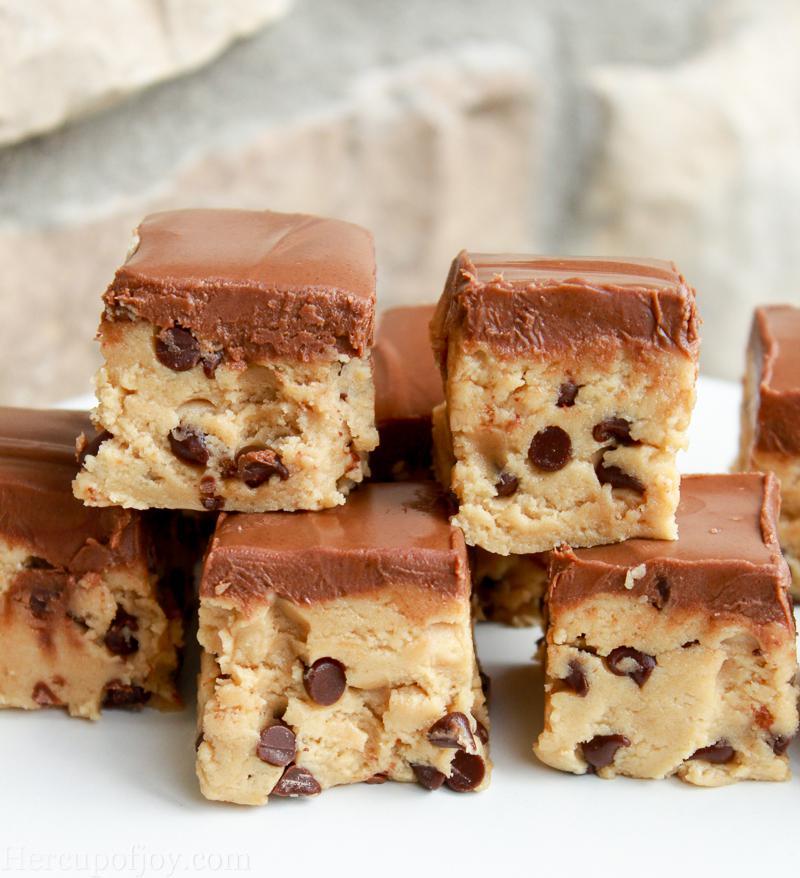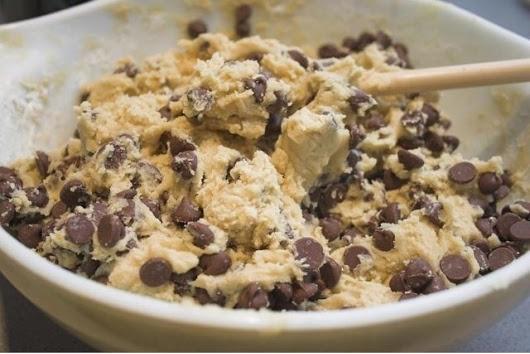The first image is the image on the left, the second image is the image on the right. Considering the images on both sides, is "Both images show unfinished cookie dough with chocolate chips." valid? Answer yes or no. No. The first image is the image on the left, the second image is the image on the right. For the images displayed, is the sentence "The image on the right contains a bowl of cookie dough with a wooden spoon in it." factually correct? Answer yes or no. Yes. 